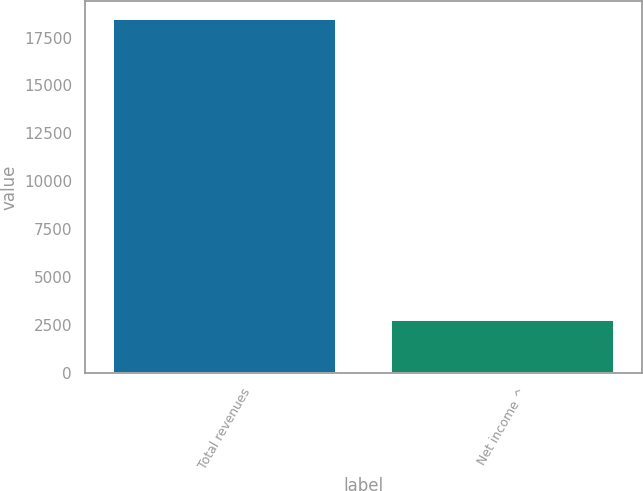<chart> <loc_0><loc_0><loc_500><loc_500><bar_chart><fcel>Total revenues<fcel>Net income ^<nl><fcel>18485<fcel>2758<nl></chart> 